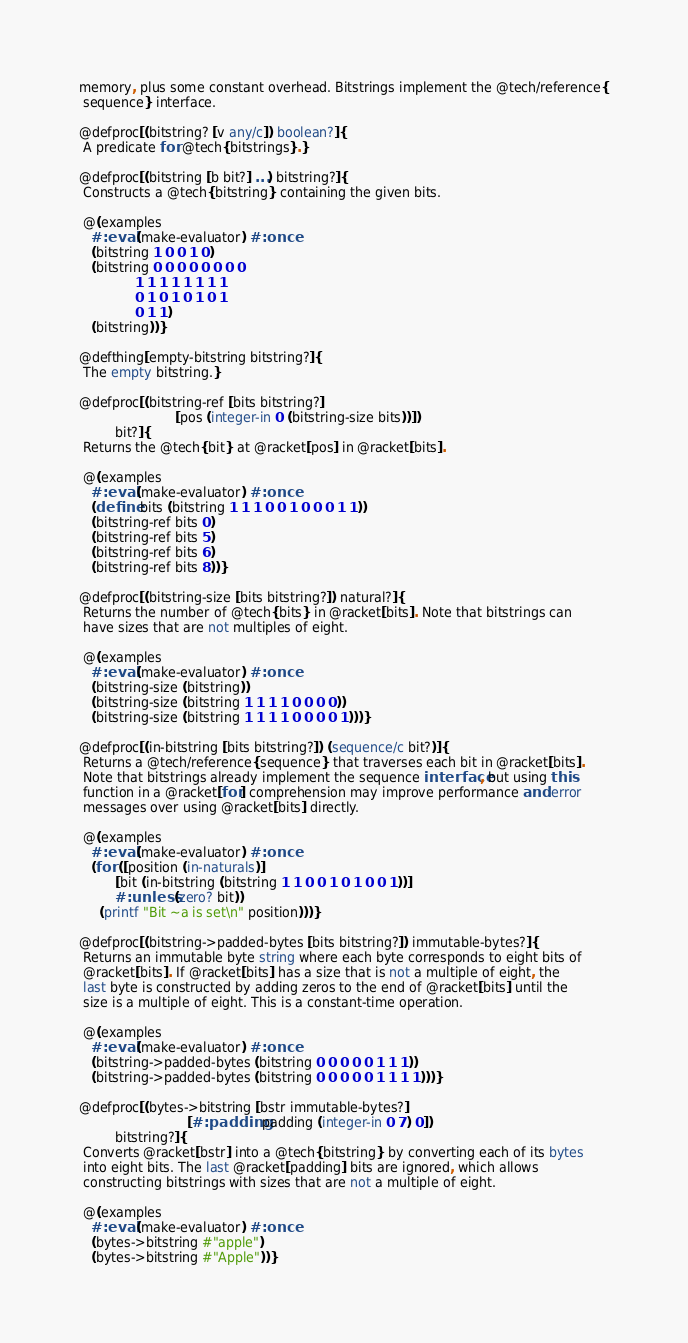<code> <loc_0><loc_0><loc_500><loc_500><_Racket_>memory, plus some constant overhead. Bitstrings implement the @tech/reference{
 sequence} interface.

@defproc[(bitstring? [v any/c]) boolean?]{
 A predicate for @tech{bitstrings}.}

@defproc[(bitstring [b bit?] ...) bitstring?]{
 Constructs a @tech{bitstring} containing the given bits.

 @(examples
   #:eval (make-evaluator) #:once
   (bitstring 1 0 0 1 0)
   (bitstring 0 0 0 0 0 0 0 0
              1 1 1 1 1 1 1 1
              0 1 0 1 0 1 0 1
              0 1 1)
   (bitstring))}

@defthing[empty-bitstring bitstring?]{
 The empty bitstring.}

@defproc[(bitstring-ref [bits bitstring?]
                        [pos (integer-in 0 (bitstring-size bits))])
         bit?]{
 Returns the @tech{bit} at @racket[pos] in @racket[bits].

 @(examples
   #:eval (make-evaluator) #:once
   (define bits (bitstring 1 1 1 0 0 1 0 0 0 1 1))
   (bitstring-ref bits 0)
   (bitstring-ref bits 5)
   (bitstring-ref bits 6)
   (bitstring-ref bits 8))}

@defproc[(bitstring-size [bits bitstring?]) natural?]{
 Returns the number of @tech{bits} in @racket[bits]. Note that bitstrings can
 have sizes that are not multiples of eight.

 @(examples
   #:eval (make-evaluator) #:once
   (bitstring-size (bitstring))
   (bitstring-size (bitstring 1 1 1 1 0 0 0 0))
   (bitstring-size (bitstring 1 1 1 1 0 0 0 0 1)))}

@defproc[(in-bitstring [bits bitstring?]) (sequence/c bit?)]{
 Returns a @tech/reference{sequence} that traverses each bit in @racket[bits].
 Note that bitstrings already implement the sequence interface, but using this
 function in a @racket[for] comprehension may improve performance and error
 messages over using @racket[bits] directly.

 @(examples
   #:eval (make-evaluator) #:once
   (for ([position (in-naturals)]
         [bit (in-bitstring (bitstring 1 1 0 0 1 0 1 0 0 1))]
         #:unless (zero? bit))
     (printf "Bit ~a is set\n" position)))}

@defproc[(bitstring->padded-bytes [bits bitstring?]) immutable-bytes?]{
 Returns an immutable byte string where each byte corresponds to eight bits of
 @racket[bits]. If @racket[bits] has a size that is not a multiple of eight, the
 last byte is constructed by adding zeros to the end of @racket[bits] until the
 size is a multiple of eight. This is a constant-time operation.

 @(examples
   #:eval (make-evaluator) #:once
   (bitstring->padded-bytes (bitstring 0 0 0 0 0 1 1 1))
   (bitstring->padded-bytes (bitstring 0 0 0 0 0 1 1 1 1)))}

@defproc[(bytes->bitstring [bstr immutable-bytes?]
                           [#:padding padding (integer-in 0 7) 0])
         bitstring?]{
 Converts @racket[bstr] into a @tech{bitstring} by converting each of its bytes
 into eight bits. The last @racket[padding] bits are ignored, which allows
 constructing bitstrings with sizes that are not a multiple of eight.

 @(examples
   #:eval (make-evaluator) #:once
   (bytes->bitstring #"apple")
   (bytes->bitstring #"Apple"))}
</code> 